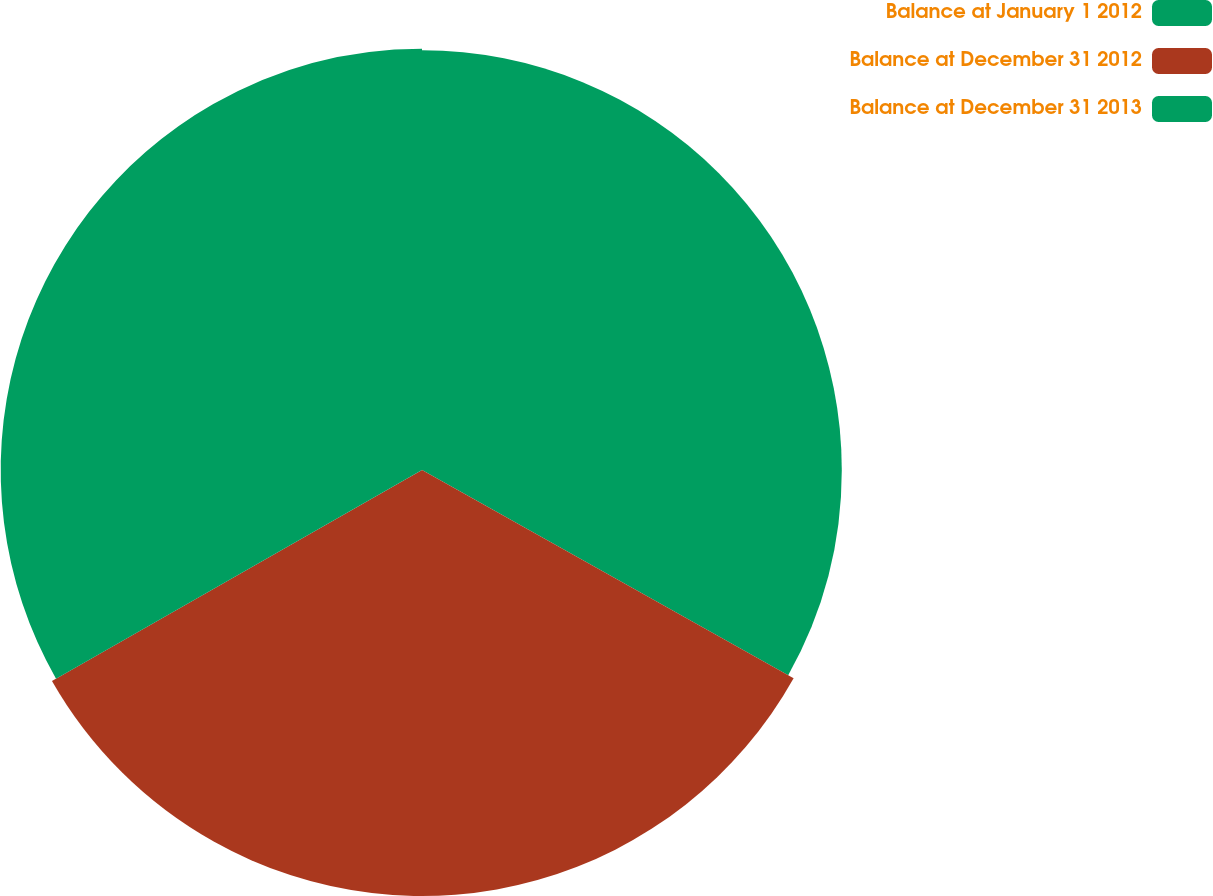Convert chart to OTSL. <chart><loc_0><loc_0><loc_500><loc_500><pie_chart><fcel>Balance at January 1 2012<fcel>Balance at December 31 2012<fcel>Balance at December 31 2013<nl><fcel>33.13%<fcel>33.62%<fcel>33.25%<nl></chart> 